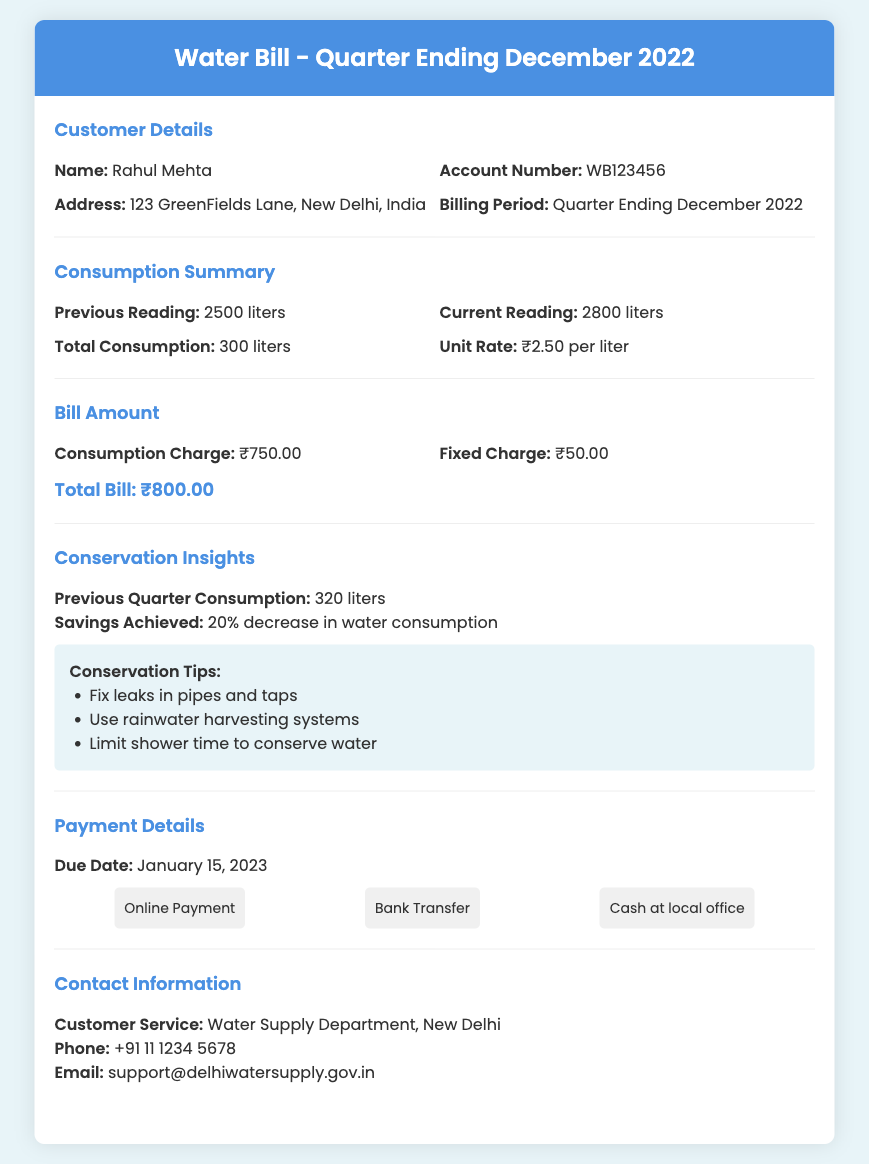What is the customer name? The customer name is specified in the Customer Details section of the document.
Answer: Rahul Mehta What is the total bill amount? The total bill amount is indicated in the Bill Amount section of the document.
Answer: ₹800.00 What is the unit rate for consumption? The unit rate for consumption is mentioned in the Consumption Summary section of the document.
Answer: ₹2.50 per liter What is the percentage of savings achieved? The percentage of savings achieved is found in the Conservation Insights section of the document.
Answer: 20% What is the previous quarter's consumption? The previous quarter's consumption is provided in the Conservation Insights section.
Answer: 320 liters What is the due date for the bill? The due date for the bill is mentioned in the Payment Details section.
Answer: January 15, 2023 What tips are provided for conservation? The conservation tips are outlined in the Conservation Insights section.
Answer: Fix leaks in pipes and taps, Use rainwater harvesting systems, Limit shower time to conserve water What is the customer service phone number? The customer service phone number is provided in the Contact Information section of the document.
Answer: +91 11 1234 5678 What is the total consumption for this bill? The total consumption is specified in the Consumption Summary section of the bill.
Answer: 300 liters 